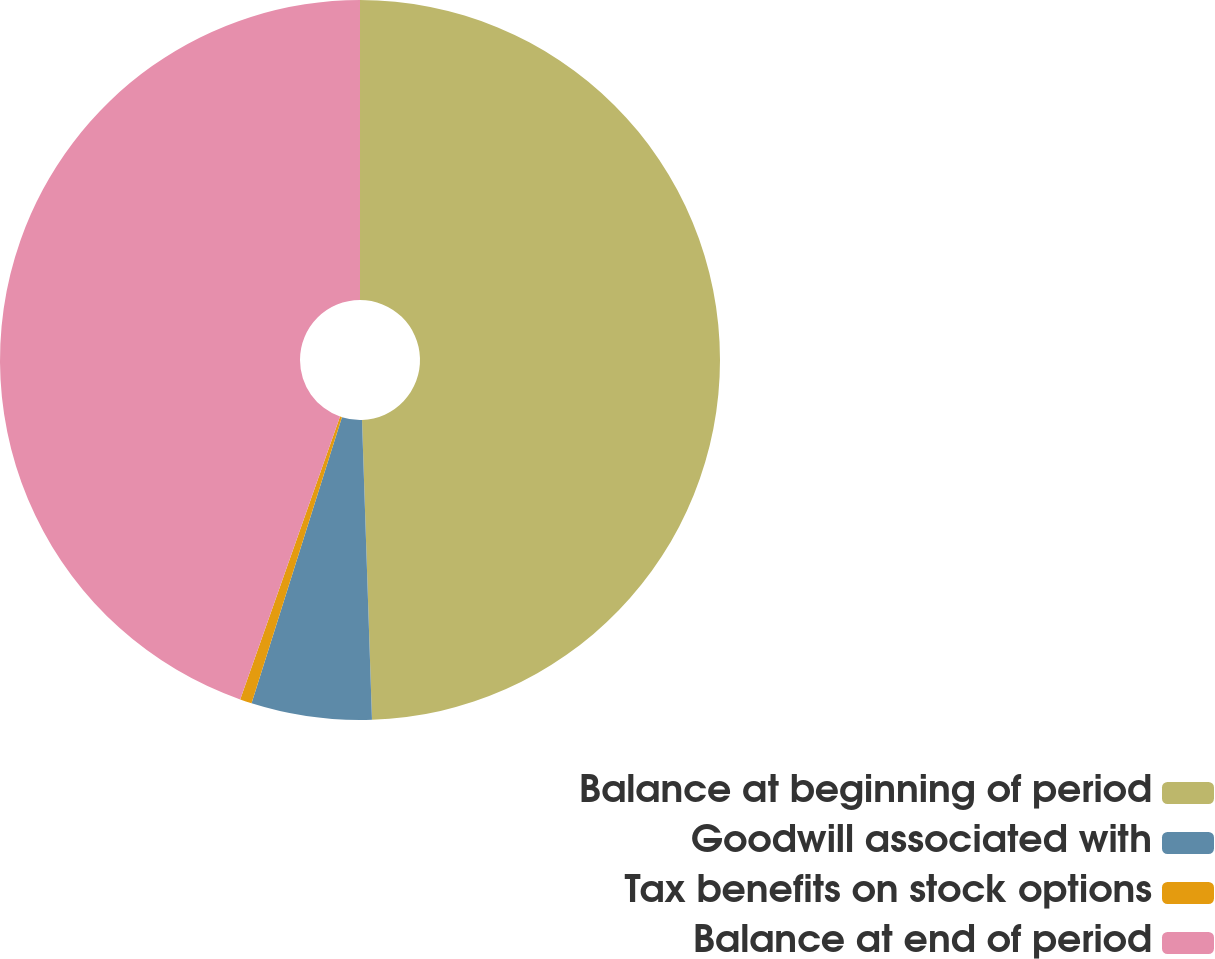<chart> <loc_0><loc_0><loc_500><loc_500><pie_chart><fcel>Balance at beginning of period<fcel>Goodwill associated with<fcel>Tax benefits on stock options<fcel>Balance at end of period<nl><fcel>49.47%<fcel>5.4%<fcel>0.53%<fcel>44.6%<nl></chart> 